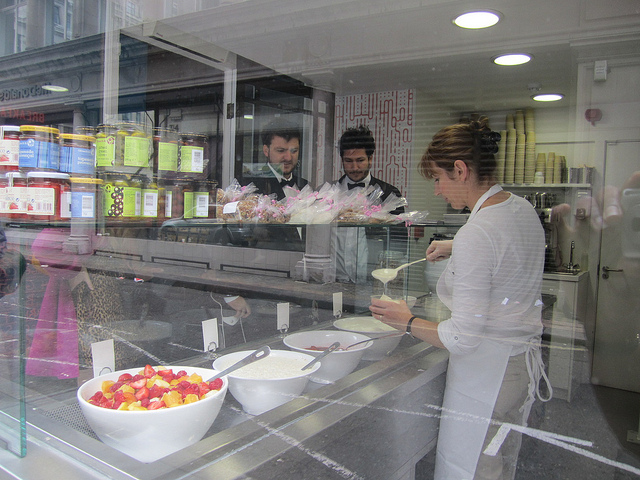Can you describe the attire of the individuals in the store? The customer outside the store is casually dressed with a light-colored top. Inside, one of the shopkeepers is wearing a dark suit indicating a formal attire, while the other one has a more casual look with a black top. Their attire suggests a professional but approachable setting. 